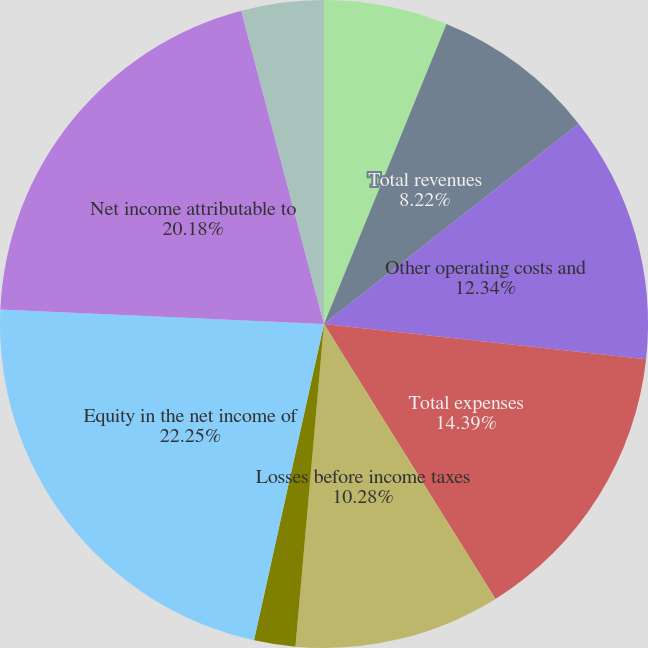Convert chart. <chart><loc_0><loc_0><loc_500><loc_500><pie_chart><fcel>Fees and other revenues<fcel>Net investment income (loss)<fcel>Total revenues<fcel>Other operating costs and<fcel>Total expenses<fcel>Losses before income taxes<fcel>Income tax benefits<fcel>Equity in the net income of<fcel>Net income attributable to<fcel>Preferred stock dividends<nl><fcel>0.0%<fcel>6.17%<fcel>8.22%<fcel>12.34%<fcel>14.39%<fcel>10.28%<fcel>2.06%<fcel>22.24%<fcel>20.18%<fcel>4.11%<nl></chart> 